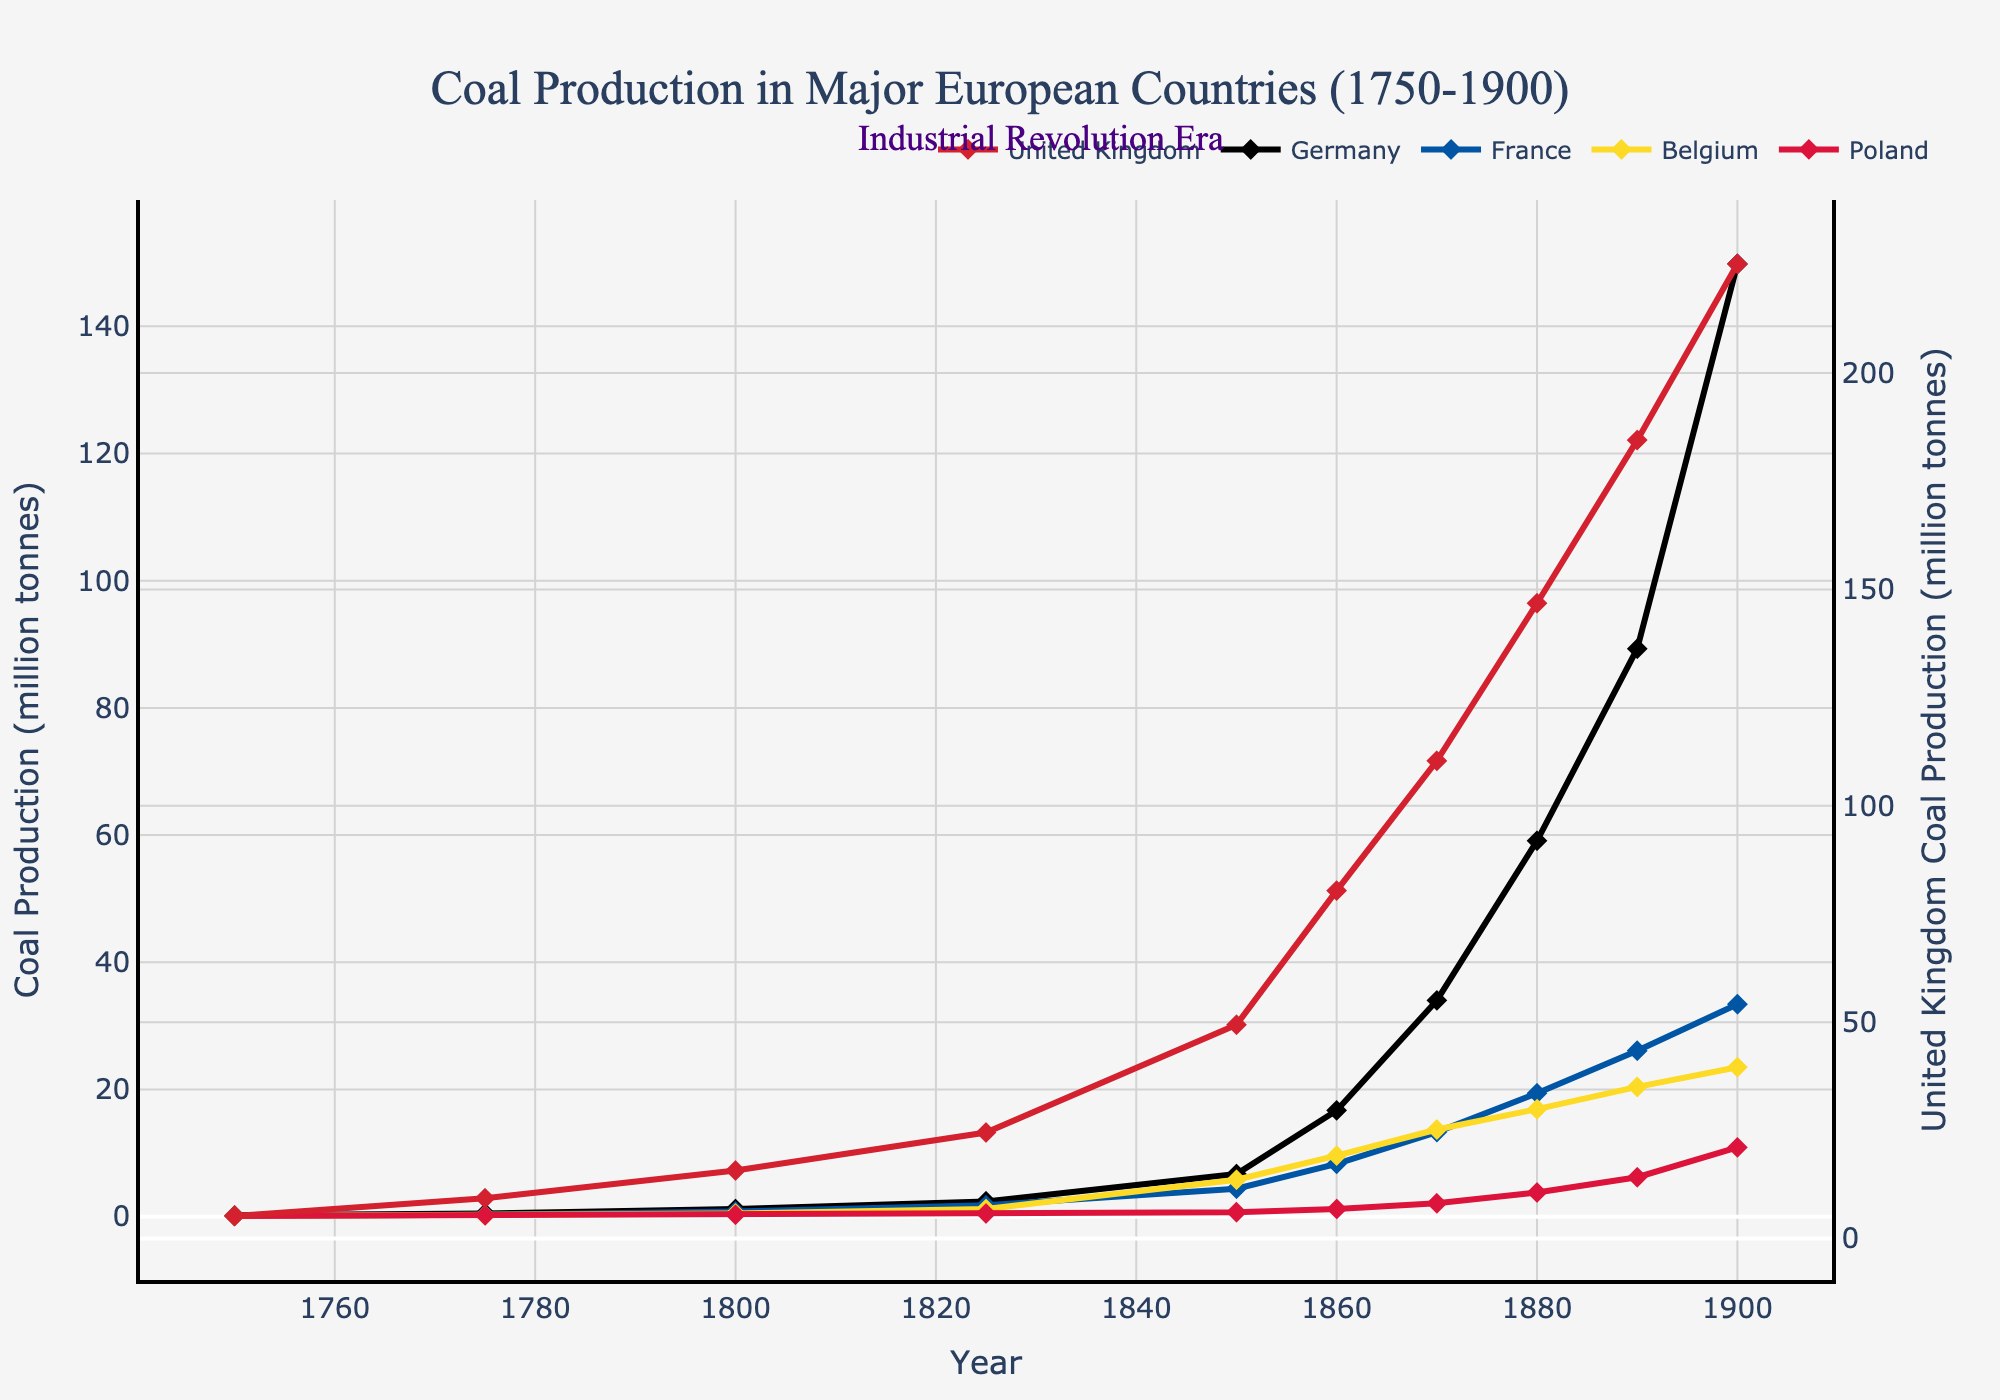Which country had the highest coal production in 1900? By looking at the end of the lines for the year 1900 in the chart, the United Kingdom's line is higher than the others.
Answer: United Kingdom Which year did Germany's coal production first surpass 50 million tonnes? By tracing Germany's line, we see it passes the 50 million tonne mark between 1870 and 1880, so the year is 1880.
Answer: 1880 Compare the coal production of Germany and France in 1860. Which one produced more, and by how much? Referencing the chart for the year 1860, Germany's production was much higher than France's: Germany produced 16.7 million tonnes, while France produced 8.3 million tonnes. The difference is 16.7 - 8.3 = 8.4 million tonnes.
Answer: Germany by 8.4 million tonnes How did Poland's coal production in 1900 compare to Belgium's coal production in 1850? Observing the chart, Poland's production in 1900 was 10.9 million tonnes, and Belgium's production in 1850 was 5.8 million tonnes, so Poland had higher production.
Answer: Poland had higher production What is the approximate increase in coal production for the United Kingdom from 1750 to 1800? By locating the points for the United Kingdom at 1750 and 1800, the increase is calculated as 15.7 - 5.2 = 10.5 million tonnes.
Answer: 10.5 million tonnes Which country showed the most rapid increase in coal production between 1750 and 1850? Looking at the steepness of the lines over these years, the United Kingdom's line shows a rapid and significant increase compared to the other countries.
Answer: United Kingdom What was the coal production gap between the United Kingdom and Poland in 1900? By locating the values for these countries in 1900, the coal production for the United Kingdom was 225.2 million tonnes, and for Poland, it was 10.9 million tonnes. The gap is 225.2 - 10.9 = 214.3 million tonnes.
Answer: 214.3 million tonnes How many countries had coal production exceeding 20 million tonnes by 1900? The chart shows that by 1900, the United Kingdom, Germany, France, and Belgium all exceeded 20 million tonnes, totaling four countries.
Answer: Four countries What is the average coal production in France for the years 1750, 1800, and 1900? Summing France's production for these years gives 0.1 + 0.8 + 33.4 = 34.3. The average is 34.3 / 3 = 11.43 million tonnes.
Answer: 11.43 million tonnes During which period did Belgium's coal production increase the most rapidly? By observing the overall trend of Belgium's line, the period between 1825 and 1850 shows a steep increase from 1.2 million tonnes to 5.8 million tonnes.
Answer: 1825-1850 